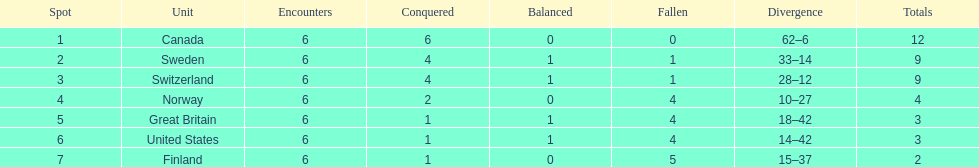Which team won more matches, finland or norway? Norway. 